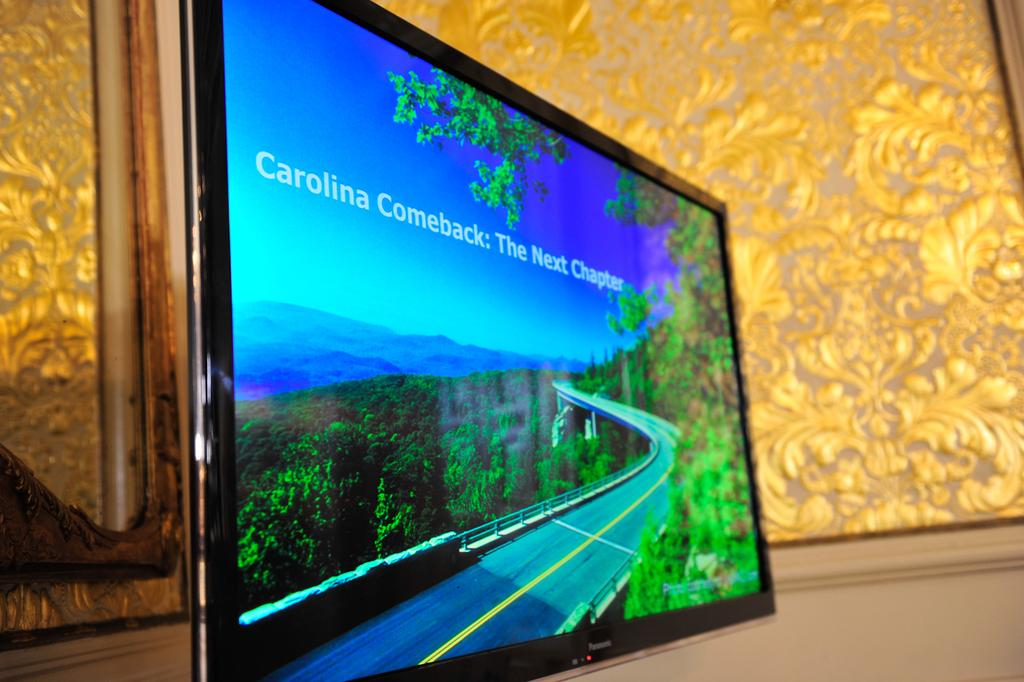<image>
Provide a brief description of the given image. A large screen which has the words Carolina Comeback on it. 